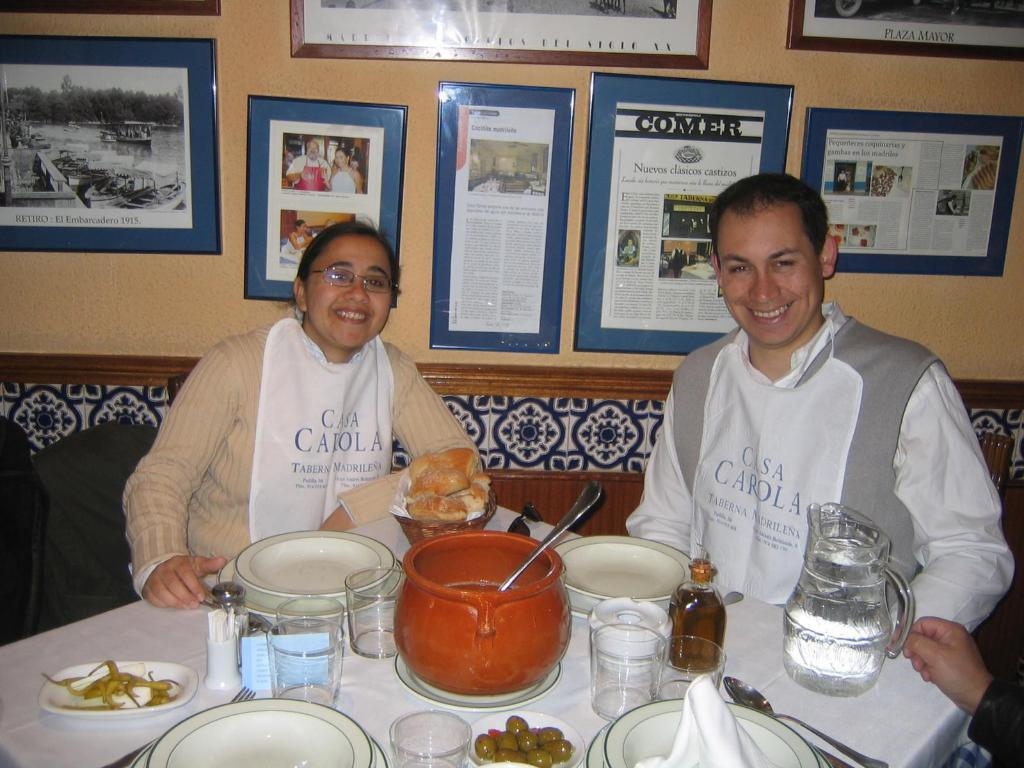How many people are present in the image? There are two people, a man and a woman, present in the image. What are the man and woman doing in the image? The man and woman are sitting in front of a table. What items can be seen on the table? There are bowls, plates, glasses, a jug, and bottles on the table. What is visible on the wall behind the man and woman? There are many photographs on the wall behind them. What type of organization do the bears in the image belong to? There are no bears present in the image, so it is not possible to determine the type of organization they might belong to. 